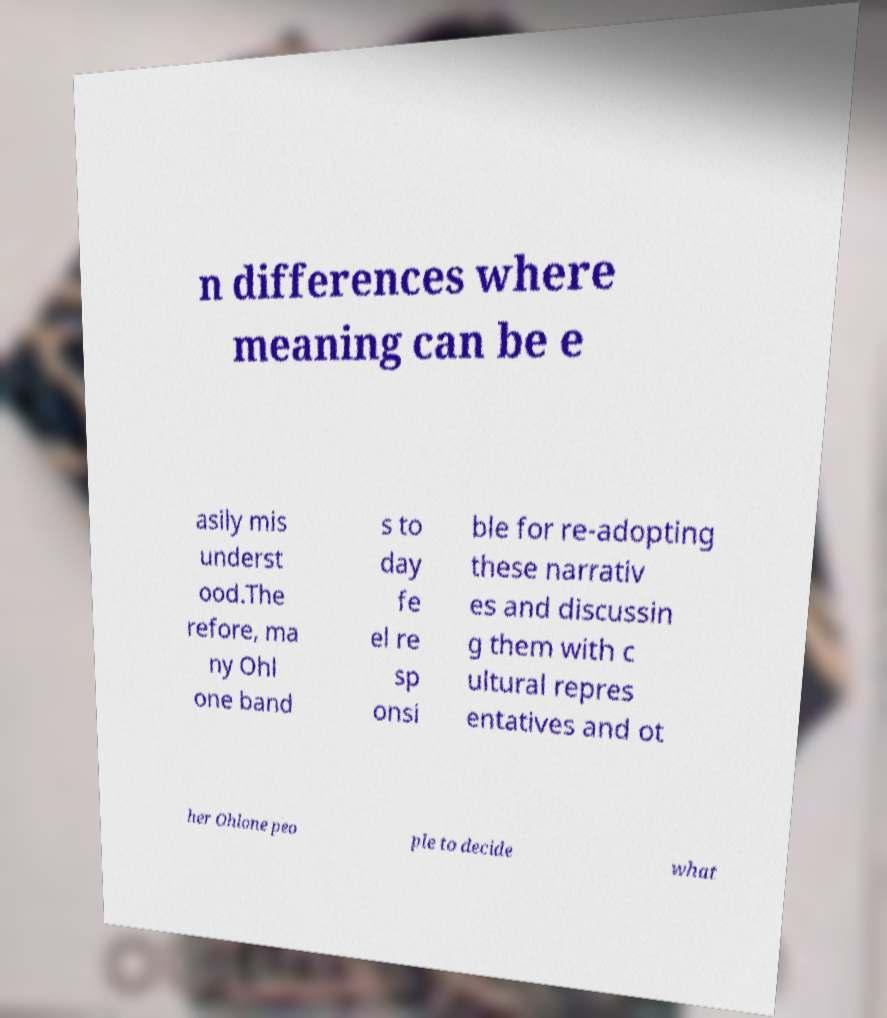Could you assist in decoding the text presented in this image and type it out clearly? n differences where meaning can be e asily mis underst ood.The refore, ma ny Ohl one band s to day fe el re sp onsi ble for re-adopting these narrativ es and discussin g them with c ultural repres entatives and ot her Ohlone peo ple to decide what 